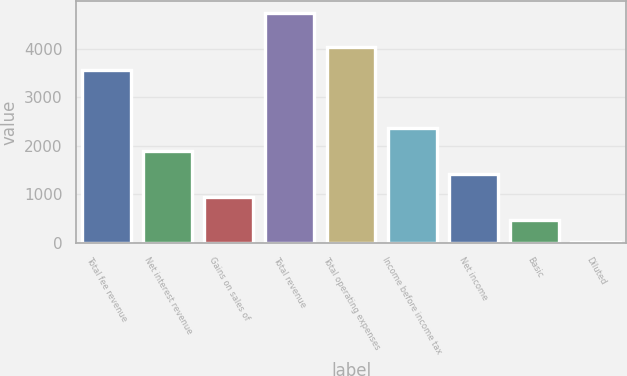Convert chart. <chart><loc_0><loc_0><loc_500><loc_500><bar_chart><fcel>Total fee revenue<fcel>Net interest revenue<fcel>Gains on sales of<fcel>Total revenue<fcel>Total operating expenses<fcel>Income before income tax<fcel>Net income<fcel>Basic<fcel>Diluted<nl><fcel>3556<fcel>1894.91<fcel>948.53<fcel>4734<fcel>4029.18<fcel>2368.1<fcel>1421.72<fcel>475.34<fcel>2.15<nl></chart> 